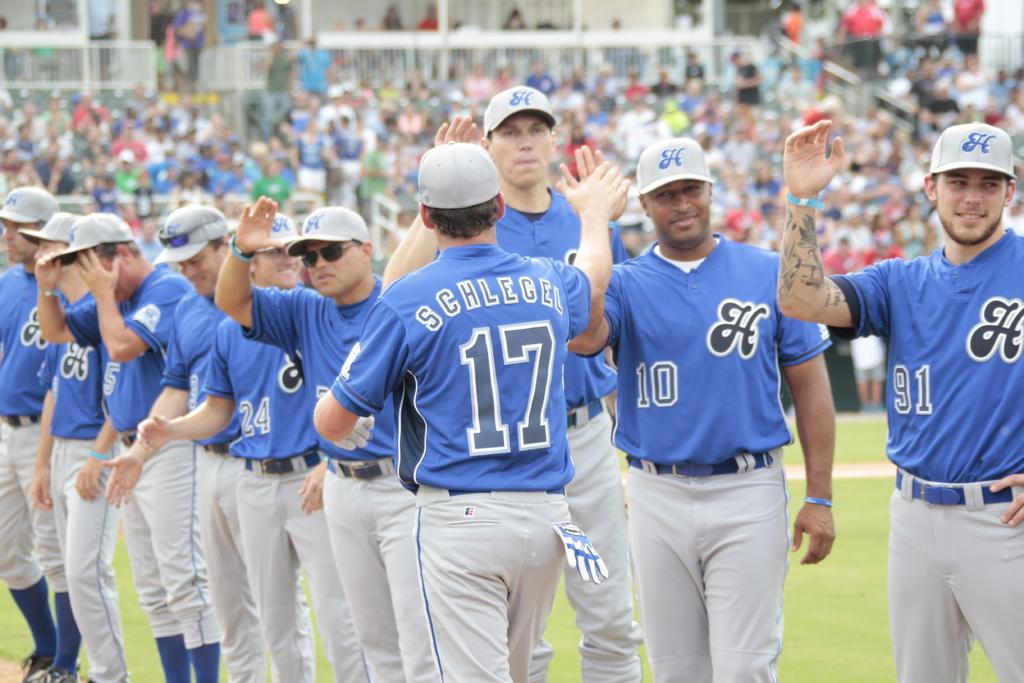<image>
Offer a succinct explanation of the picture presented. A team of baseball players in blue and grey, one with Schlegle 17 on their shirt. 